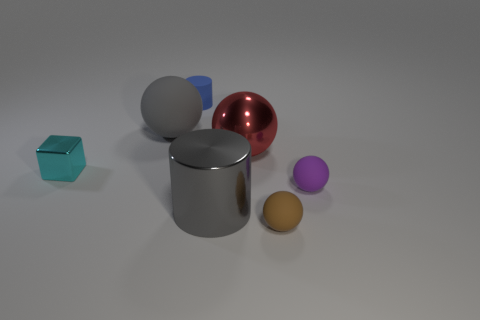Are there fewer gray balls in front of the brown matte thing than rubber balls left of the large gray cylinder?
Your answer should be compact. Yes. What shape is the rubber thing that is on the left side of the purple thing and in front of the block?
Provide a short and direct response. Sphere. How many big shiny objects are the same shape as the tiny purple thing?
Give a very brief answer. 1. What size is the blue cylinder that is made of the same material as the purple object?
Make the answer very short. Small. Are there more small blue matte things than things?
Ensure brevity in your answer.  No. The small thing left of the blue thing is what color?
Keep it short and to the point. Cyan. How big is the object that is on the left side of the gray cylinder and in front of the large gray matte object?
Provide a succinct answer. Small. How many cylinders have the same size as the gray matte object?
Provide a succinct answer. 1. There is a large red thing that is the same shape as the small brown object; what is it made of?
Provide a succinct answer. Metal. Do the small cyan shiny thing and the large matte thing have the same shape?
Make the answer very short. No. 